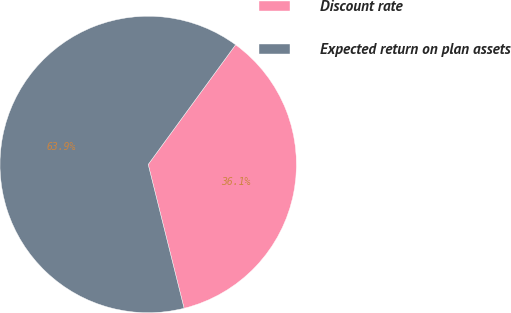Convert chart. <chart><loc_0><loc_0><loc_500><loc_500><pie_chart><fcel>Discount rate<fcel>Expected return on plan assets<nl><fcel>36.07%<fcel>63.93%<nl></chart> 